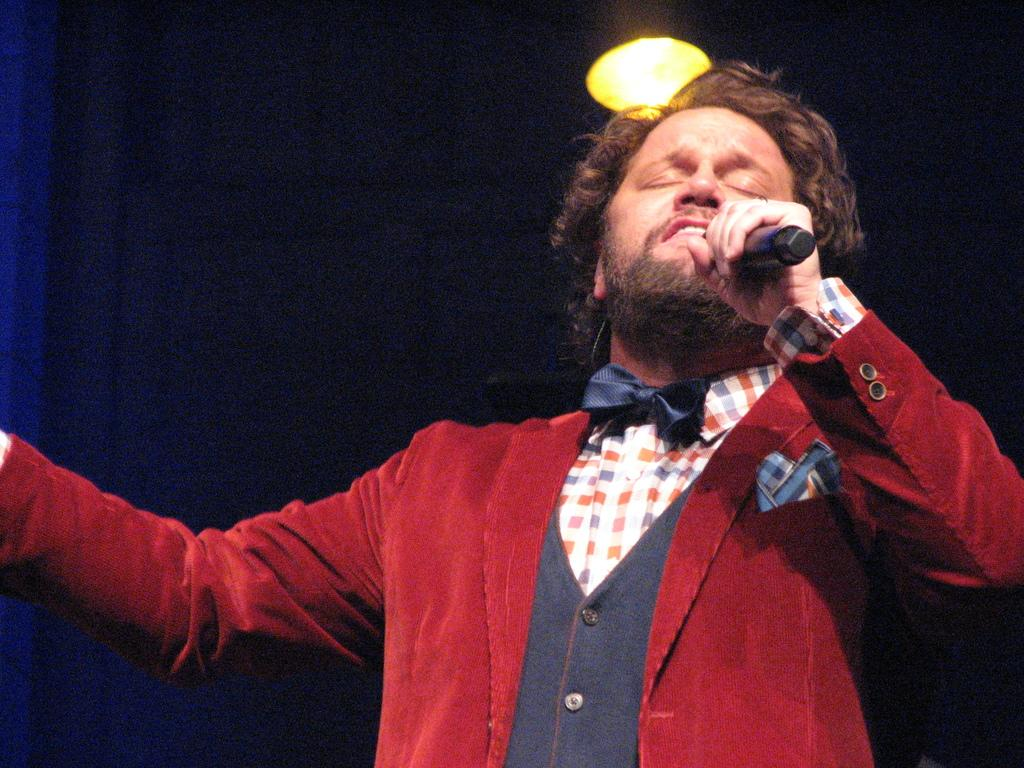What is the main subject of the image? The main subject of the image is a man. Can you describe the man's clothing in the image? The man is wearing a red suit and a check shirt. What is the man doing in the image? The man is singing. What can be seen in the background of the image? There is a light in the background of the image. How does the man's singing compare to the height of the mountain in the image? There is no mountain present in the image, so it is not possible to make a comparison between the man's singing and the height of a mountain. 